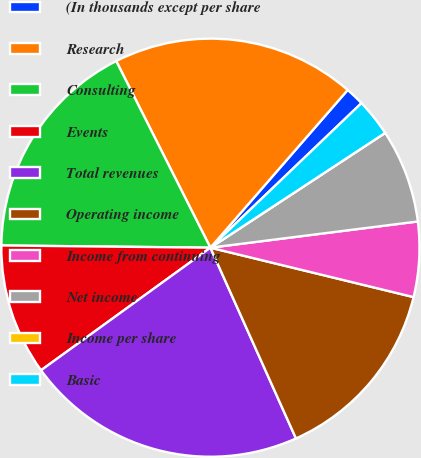Convert chart. <chart><loc_0><loc_0><loc_500><loc_500><pie_chart><fcel>(In thousands except per share<fcel>Research<fcel>Consulting<fcel>Events<fcel>Total revenues<fcel>Operating income<fcel>Income from continuing<fcel>Net income<fcel>Income per share<fcel>Basic<nl><fcel>1.45%<fcel>18.84%<fcel>17.39%<fcel>10.14%<fcel>21.74%<fcel>14.49%<fcel>5.8%<fcel>7.25%<fcel>0.0%<fcel>2.9%<nl></chart> 